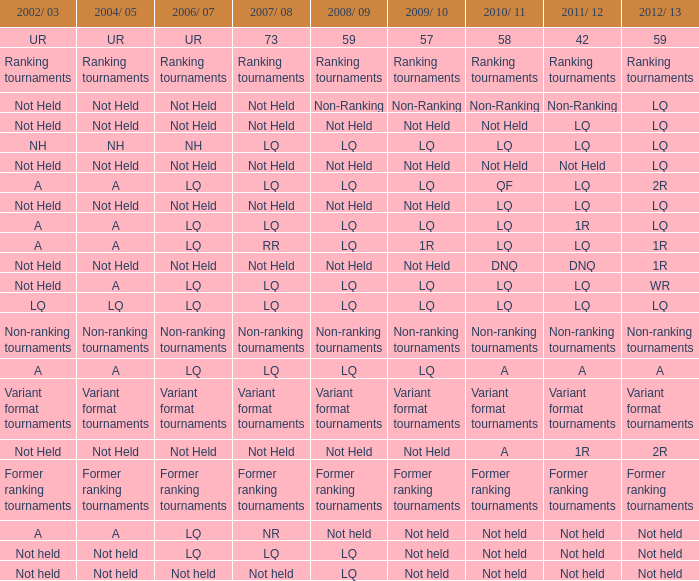Name the 2008/09 with 2004/05 of ranking tournaments Ranking tournaments. 